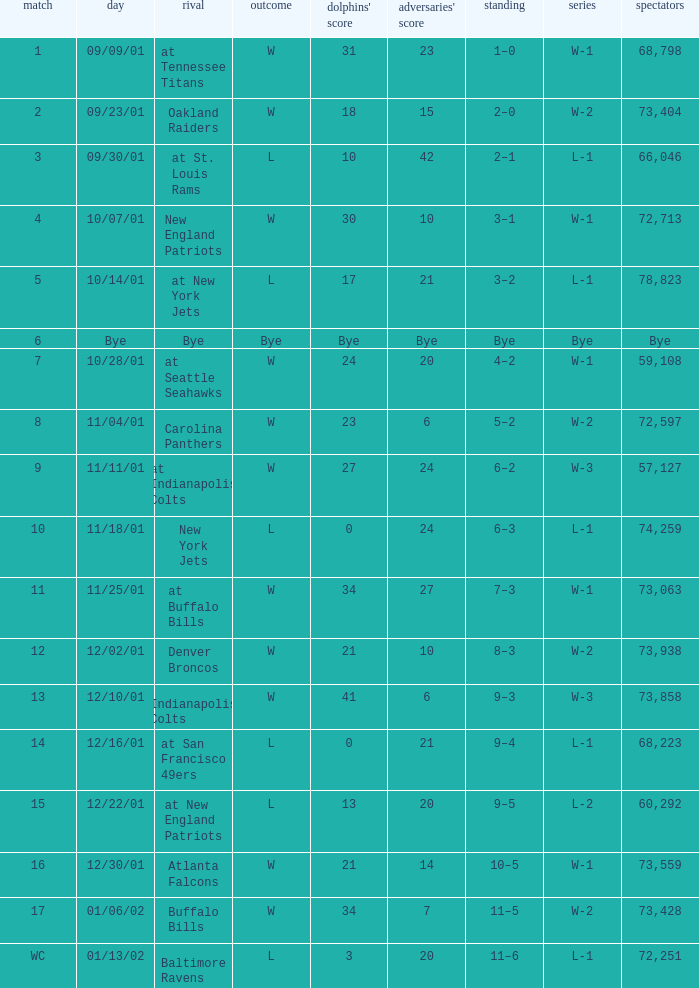How many opponents points were there on 11/11/01? 24.0. 